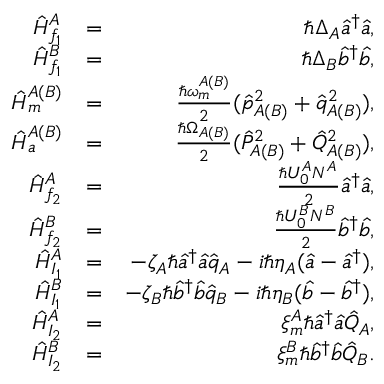Convert formula to latex. <formula><loc_0><loc_0><loc_500><loc_500>\begin{array} { r l r } { \hat { H } _ { f _ { 1 } } ^ { A } } & { = } & { \hbar { \Delta } _ { A } \hat { a } ^ { \dagger } \hat { a } , } \\ { \hat { H } _ { f _ { 1 } } ^ { B } } & { = } & { \hbar { \Delta } _ { B } \hat { b } ^ { \dagger } \hat { b } , } \\ { \hat { H } _ { m } ^ { A ( B ) } } & { = } & { \frac { \hbar { \omega } _ { m } ^ { A ( B ) } } { 2 } ( \hat { p } _ { A ( B ) } ^ { 2 } + \hat { q } _ { A ( B ) } ^ { 2 } ) , } \\ { \hat { H } _ { a } ^ { A ( B ) } } & { = } & { \frac { \hbar { \Omega } _ { A ( B ) } } { 2 } ( \hat { P } _ { A ( B ) } ^ { 2 } + \hat { Q } _ { A ( B ) } ^ { 2 } ) , } \\ { \hat { H } _ { f _ { 2 } } ^ { A } } & { = } & { \frac { \hbar { U } _ { 0 } ^ { A } N ^ { A } } { 2 } \hat { a } ^ { \dagger } \hat { a } , } \\ { \hat { H } _ { f _ { 2 } } ^ { B } } & { = } & { \frac { \hbar { U } _ { 0 } ^ { B } N ^ { B } } { 2 } \hat { b } ^ { \dagger } \hat { b } , } \\ { \hat { H } _ { I _ { 1 } } ^ { A } } & { = } & { - \zeta _ { A } \hbar { \hat } { a } ^ { \dagger } \hat { a } \hat { q } _ { A } - i \hbar { \eta } _ { A } ( \hat { a } - \hat { a } ^ { \dagger } ) , } \\ { \hat { H } _ { I _ { 1 } } ^ { B } } & { = } & { - \zeta _ { B } \hbar { \hat } { b } ^ { \dagger } \hat { b } \hat { q } _ { B } - i \hbar { \eta } _ { B } ( \hat { b } - \hat { b } ^ { \dagger } ) , } \\ { \hat { H } _ { I _ { 2 } } ^ { A } } & { = } & { \xi _ { m } ^ { A } \hbar { \hat } { a } ^ { \dagger } \hat { a } \hat { Q } _ { A } , } \\ { \hat { H } _ { I _ { 2 } } ^ { B } } & { = } & { \xi _ { m } ^ { B } \hbar { \hat } { b } ^ { \dagger } \hat { b } \hat { Q } _ { B } . } \end{array}</formula> 